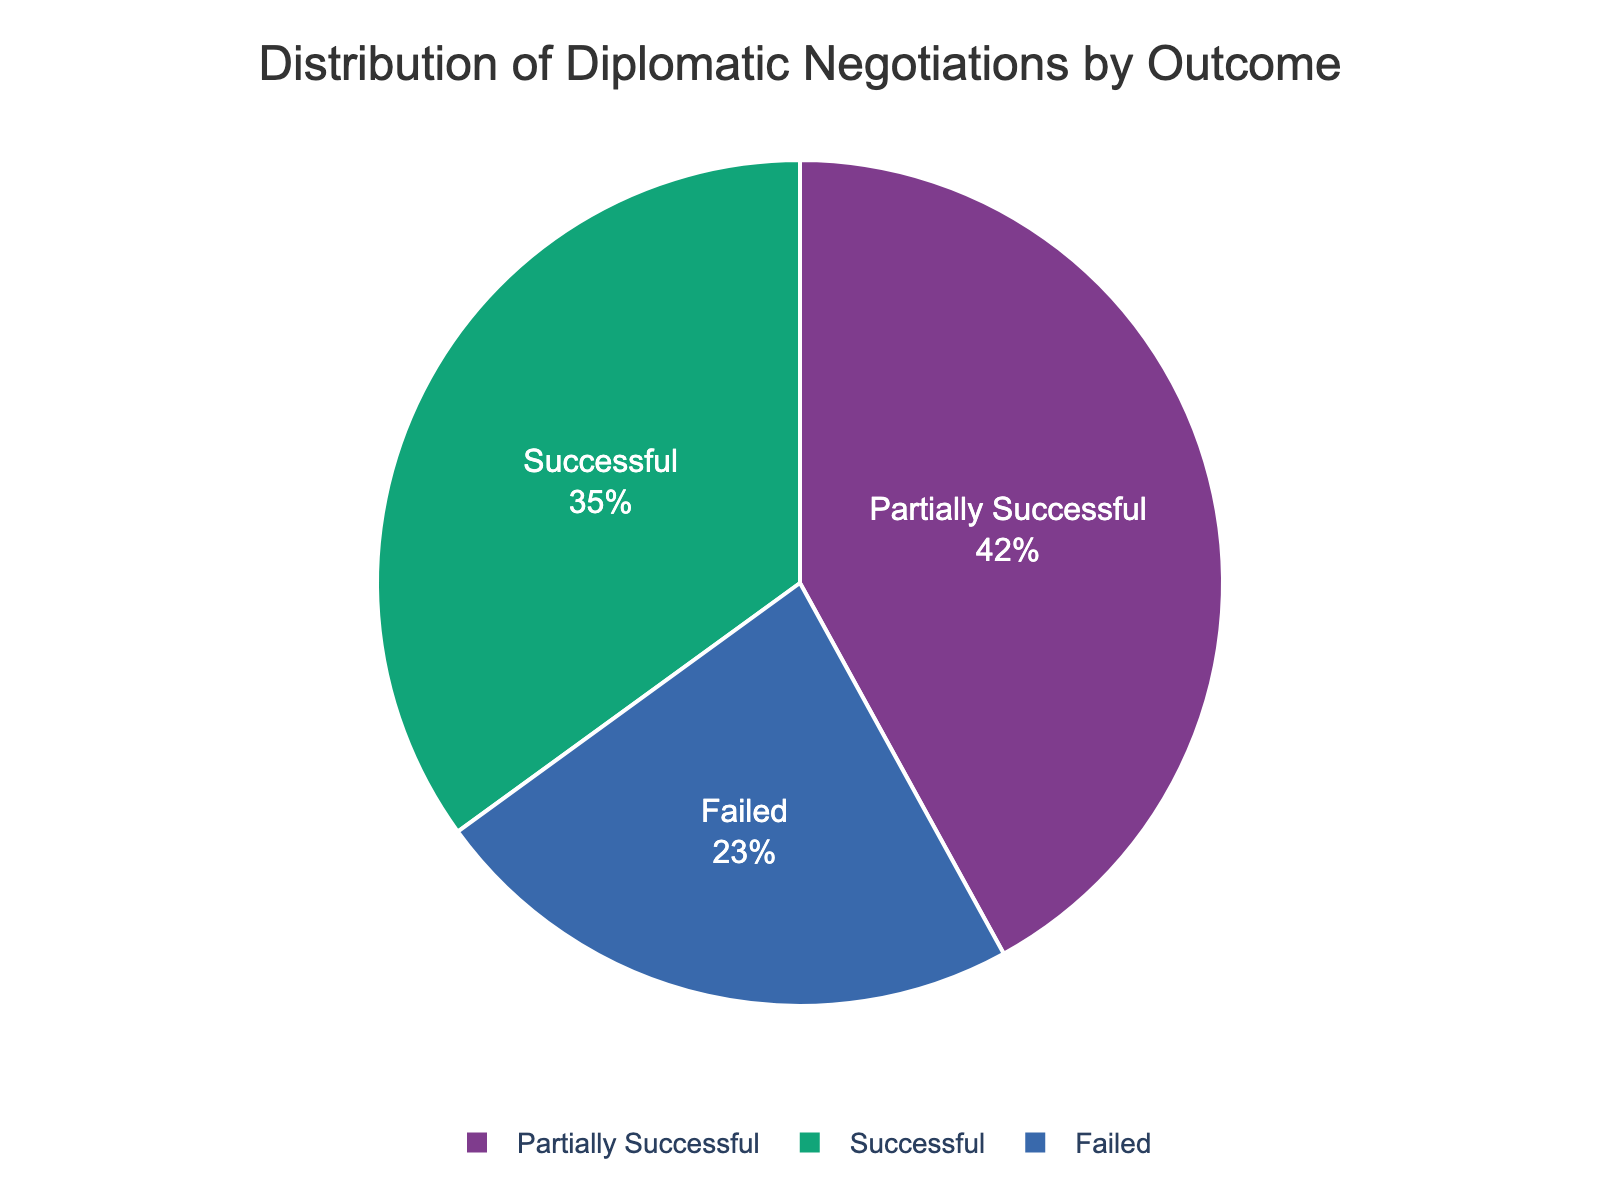What is the percentage of successful and failed negotiations combined? The pie chart shows that successful negotiations account for 35% and failed negotiations account for 23%. Adding these percentages together gives 35 + 23 = 58%.
Answer: 58% Which type of negotiation outcome has the highest percentage? The pie chart indicates that partially successful negotiations have the highest percentage at 42%.
Answer: Partially successful How does the percentage of successful negotiations compare to the percentage of failed negotiations? From the pie chart, the successful negotiations percentage (35%) is greater than the failed negotiations percentage (23%).
Answer: Successful is greater What is the difference in percentage between the partially successful and failed negotiations? The pie chart shows partially successful negotiations are 42% and failed negotiations are 23%. The difference is 42 - 23 = 19%.
Answer: 19% How much more common are partially successful negotiations compared to successful negotiations? The pie chart indicates that partially successful negotiations are 42% and successful negotiations are 35%. The difference is 42 - 35 = 7%.
Answer: 7% What is the ratio of partially successful negotiations to failed negotiations? The pie chart shows that partially successful negotiations account for 42% and failed negotiations account for 23%. The ratio is 42:23, which can be simplified to approximately 1.83:1.
Answer: 1.83:1 If you were to visualize the percentage of failed negotiations as a part of a whole, how would you describe its size relative to the other two categories? The pie chart indicates that failed negotiations make up 23%, which is less than both successful (35%) and partially successful (42%) negotiations.
Answer: Least Between successful and partially successful negotiations, which has a larger slice of the pie and by how much? The pie chart shows that partially successful negotiations (42%) have a larger slice than successful negotiations (35%). The difference is 42 - 35 = 7%.
Answer: Partially successful by 7% What is the total percentage accounted for by successful and partially successful negotiations together? The pie chart shows successful negotiations are 35% and partially successful negotiations are 42%. Adding these gives 35 + 42 = 77%.
Answer: 77% Considering the data, what can you infer about the effectiveness of diplomatic negotiations in achieving at least partial success? The pie chart shows that partially successful and successful negotiations together account for 77%, suggesting that diplomatic negotiations are more likely to achieve at least partial success.
Answer: High effectiveness 